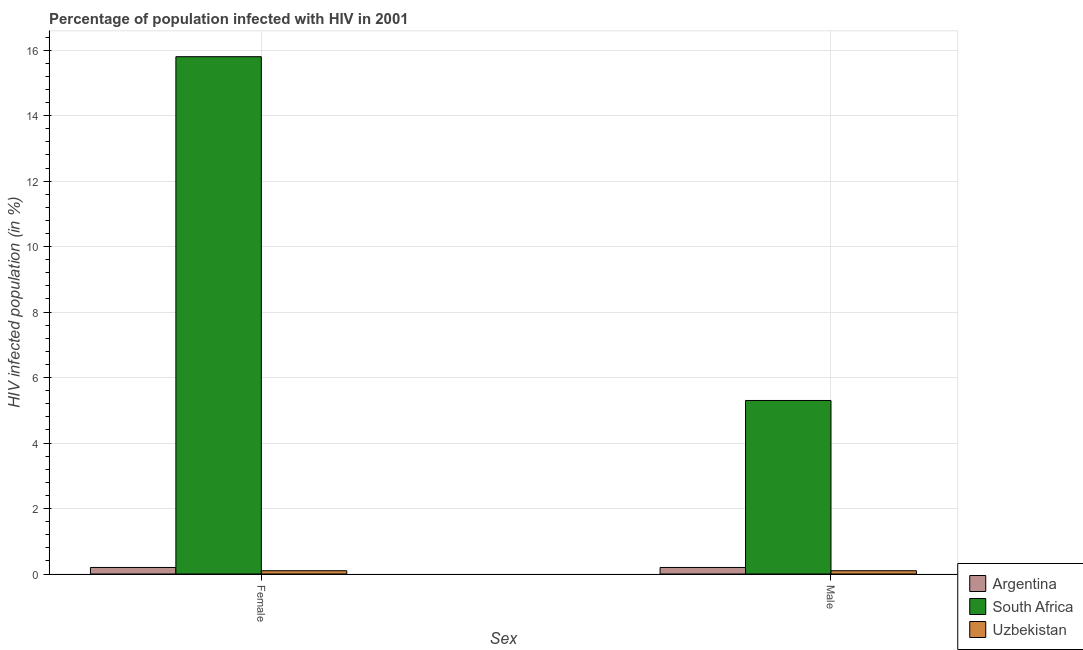Are the number of bars per tick equal to the number of legend labels?
Give a very brief answer. Yes. Are the number of bars on each tick of the X-axis equal?
Offer a terse response. Yes. How many bars are there on the 2nd tick from the left?
Offer a very short reply. 3. How many bars are there on the 2nd tick from the right?
Your answer should be compact. 3. Across all countries, what is the maximum percentage of females who are infected with hiv?
Provide a succinct answer. 15.8. In which country was the percentage of males who are infected with hiv maximum?
Offer a terse response. South Africa. In which country was the percentage of males who are infected with hiv minimum?
Provide a short and direct response. Uzbekistan. What is the total percentage of females who are infected with hiv in the graph?
Offer a very short reply. 16.1. What is the difference between the percentage of females who are infected with hiv in Argentina and that in Uzbekistan?
Offer a terse response. 0.1. What is the difference between the percentage of females who are infected with hiv in South Africa and the percentage of males who are infected with hiv in Argentina?
Make the answer very short. 15.6. What is the average percentage of males who are infected with hiv per country?
Provide a succinct answer. 1.87. In how many countries, is the percentage of males who are infected with hiv greater than 11.6 %?
Provide a short and direct response. 0. What is the ratio of the percentage of females who are infected with hiv in South Africa to that in Uzbekistan?
Provide a succinct answer. 158. Is the percentage of females who are infected with hiv in Uzbekistan less than that in Argentina?
Your answer should be compact. Yes. What does the 3rd bar from the left in Female represents?
Give a very brief answer. Uzbekistan. What does the 1st bar from the right in Male represents?
Give a very brief answer. Uzbekistan. How many bars are there?
Your answer should be compact. 6. Are all the bars in the graph horizontal?
Keep it short and to the point. No. How many countries are there in the graph?
Give a very brief answer. 3. Are the values on the major ticks of Y-axis written in scientific E-notation?
Make the answer very short. No. Does the graph contain grids?
Provide a short and direct response. Yes. Where does the legend appear in the graph?
Your answer should be very brief. Bottom right. What is the title of the graph?
Give a very brief answer. Percentage of population infected with HIV in 2001. Does "Middle East & North Africa (developing only)" appear as one of the legend labels in the graph?
Provide a succinct answer. No. What is the label or title of the X-axis?
Keep it short and to the point. Sex. What is the label or title of the Y-axis?
Provide a succinct answer. HIV infected population (in %). What is the HIV infected population (in %) of South Africa in Female?
Ensure brevity in your answer.  15.8. What is the HIV infected population (in %) in South Africa in Male?
Your response must be concise. 5.3. What is the HIV infected population (in %) in Uzbekistan in Male?
Give a very brief answer. 0.1. Across all Sex, what is the maximum HIV infected population (in %) of Argentina?
Make the answer very short. 0.2. Across all Sex, what is the maximum HIV infected population (in %) of South Africa?
Provide a succinct answer. 15.8. Across all Sex, what is the minimum HIV infected population (in %) in Argentina?
Provide a short and direct response. 0.2. What is the total HIV infected population (in %) in Argentina in the graph?
Provide a short and direct response. 0.4. What is the total HIV infected population (in %) of South Africa in the graph?
Give a very brief answer. 21.1. What is the total HIV infected population (in %) of Uzbekistan in the graph?
Make the answer very short. 0.2. What is the difference between the HIV infected population (in %) in Argentina in Female and that in Male?
Offer a very short reply. 0. What is the difference between the HIV infected population (in %) in South Africa in Female and that in Male?
Your response must be concise. 10.5. What is the difference between the HIV infected population (in %) of Argentina in Female and the HIV infected population (in %) of South Africa in Male?
Keep it short and to the point. -5.1. What is the difference between the HIV infected population (in %) of South Africa in Female and the HIV infected population (in %) of Uzbekistan in Male?
Your answer should be compact. 15.7. What is the average HIV infected population (in %) in South Africa per Sex?
Your answer should be compact. 10.55. What is the difference between the HIV infected population (in %) of Argentina and HIV infected population (in %) of South Africa in Female?
Your answer should be very brief. -15.6. What is the difference between the HIV infected population (in %) in Argentina and HIV infected population (in %) in South Africa in Male?
Make the answer very short. -5.1. What is the difference between the HIV infected population (in %) of Argentina and HIV infected population (in %) of Uzbekistan in Male?
Ensure brevity in your answer.  0.1. What is the ratio of the HIV infected population (in %) in South Africa in Female to that in Male?
Provide a short and direct response. 2.98. What is the ratio of the HIV infected population (in %) in Uzbekistan in Female to that in Male?
Make the answer very short. 1. What is the difference between the highest and the second highest HIV infected population (in %) of Argentina?
Your answer should be very brief. 0. 